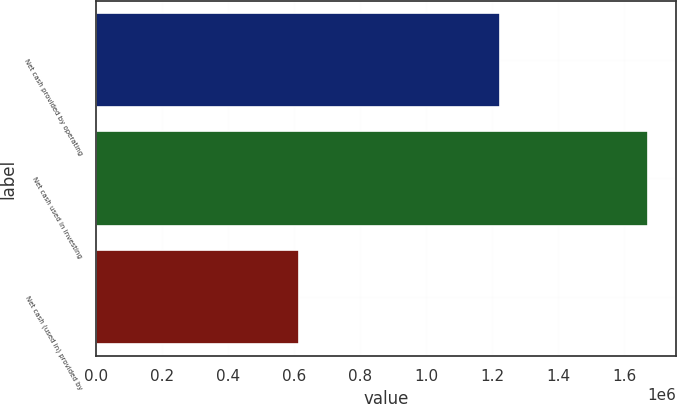Convert chart to OTSL. <chart><loc_0><loc_0><loc_500><loc_500><bar_chart><fcel>Net cash provided by operating<fcel>Net cash used in investing<fcel>Net cash (used in) provided by<nl><fcel>1.22214e+06<fcel>1.672e+06<fcel>614087<nl></chart> 